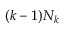Convert formula to latex. <formula><loc_0><loc_0><loc_500><loc_500>( k - 1 ) N _ { k }</formula> 